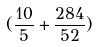<formula> <loc_0><loc_0><loc_500><loc_500>( \frac { 1 0 } { 5 } + \frac { 2 8 4 } { 5 2 } )</formula> 